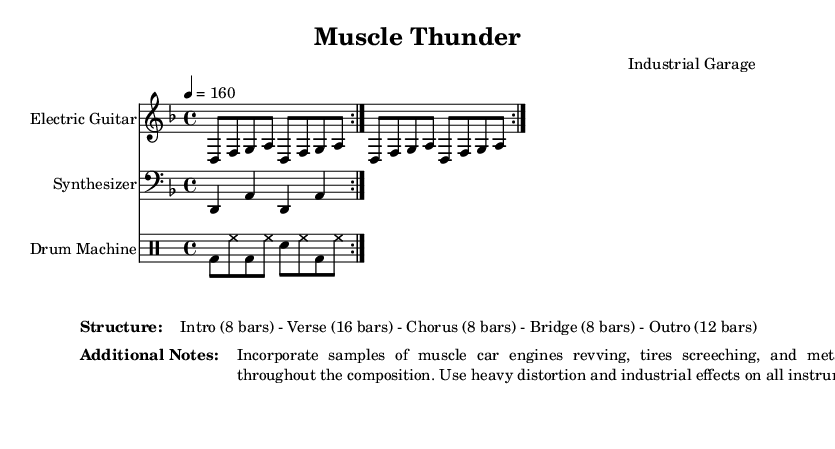What is the key signature of this music? The key signature is D minor, indicated by the presence of one flat (B flat) on the staff and the context of the piece.
Answer: D minor What is the time signature of the piece? The time signature is 4/4, shown at the beginning of the score, which indicates there are four beats in each measure.
Answer: 4/4 What is the tempo marking given in the score? The tempo marking is indicated as 4 = 160, meaning there are 160 beats per minute. This shows the intended speed of the piece.
Answer: 160 How many bars are in the Verse section? The Verse section consists of 16 bars, as outlined in the structure provided at the end of the score.
Answer: 16 bars What instruments are used in this composition? The composition features Electric Guitar, Synthesizer, and Drum Machine, as specified at the beginning of each staff in the score.
Answer: Electric Guitar, Synthesizer, Drum Machine What special effects are suggested for the instruments? It is suggested to use heavy distortion and industrial effects on all instruments, highlighting the experimental nature of the composition.
Answer: Heavy distortion and industrial effects What additional elements should be incorporated into the composition? The notes suggest incorporating samples of muscle car engines revving, tires screeching, and metal impacts throughout the composition, enhancing the industrial noise music theme.
Answer: Samples of muscle car engines, tires screeching, metal impacts 